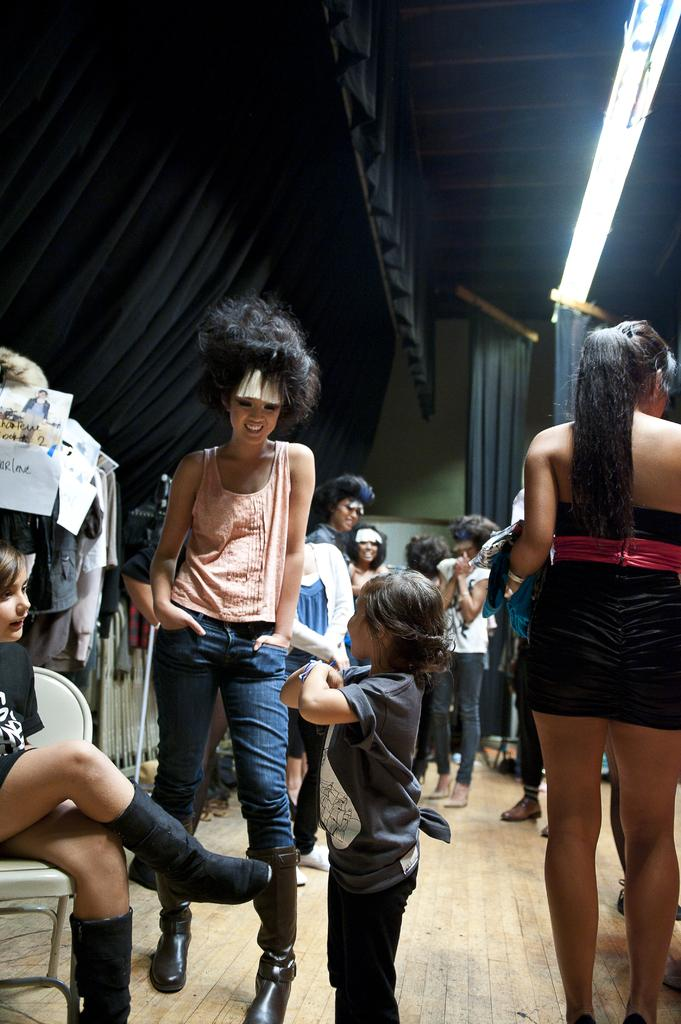How many individuals are present in the image? There are many people in the image. What is located at the bottom of the image? There is a floor at the bottom of the image. What can be seen to the left of the image? There are curtains to the left of the image. What is located at the top of the image? There is a roof at the top of the image. How many cacti are present on the table in the image? There is no table or cactus present in the image. 